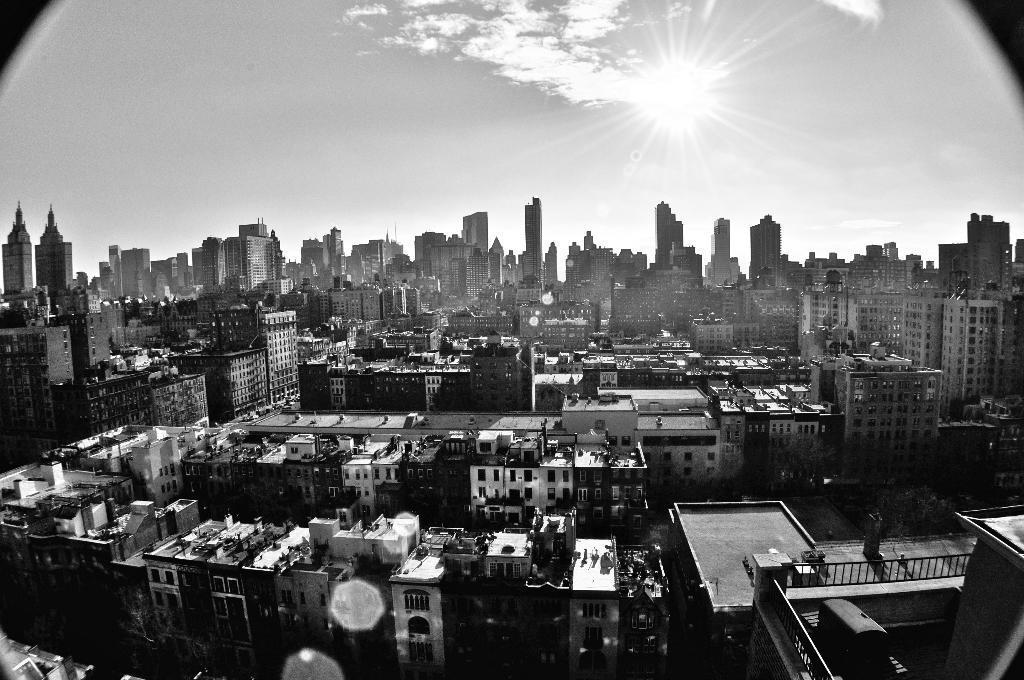Describe this image in one or two sentences. This is a black and white image of a city, where there are buildings, and in the background there is sky. 